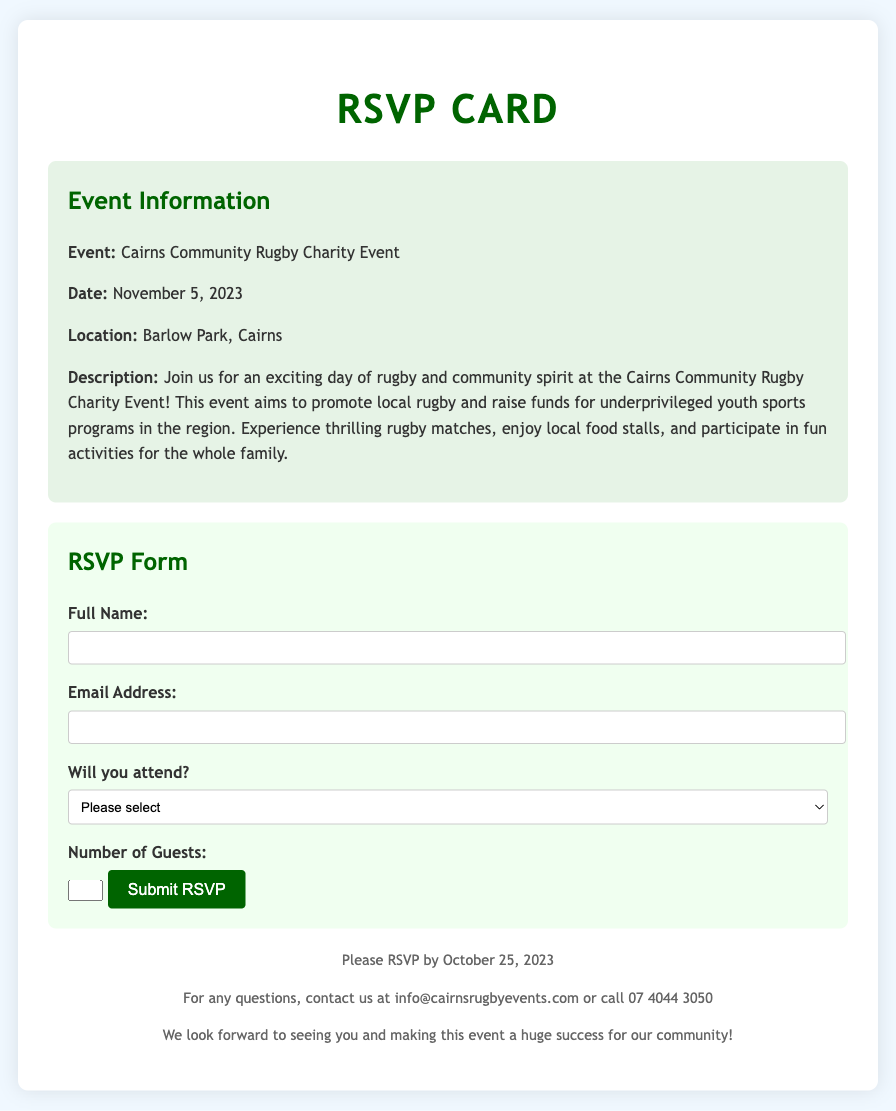What is the date of the event? The date of the Cairns Community Rugby Charity Event is explicitly stated in the document.
Answer: November 5, 2023 Where is the event taking place? The document specifies the location for the Cairns Community Rugby Charity Event.
Answer: Barlow Park, Cairns What is the main purpose of the event? The document describes the main purpose of the event, which involves promoting local rugby and fundraising.
Answer: Raise funds for underprivileged youth sports programs What is the RSVP deadline? The document mentions the last date by which attendees should RSVP for the event.
Answer: October 25, 2023 What information is required to submit the RSVP form? The document lists the necessary fields that must be filled out in the RSVP form.
Answer: Full Name, Email Address, Will you attend?, Number of Guests What activities can attendees expect at the event? The document provides an overview of activities available at the Cairns Community Rugby Charity Event.
Answer: Rugby matches, local food stalls, fun activities How can attendees reach out for questions? The document includes contact information for inquiries regarding the event.
Answer: info@cairnsrugbyevents.com or call 07 4044 3050 What is the maximum number of guests allowed? The RSVP form specifies a limit on the number of guests that can be included in the RSVP.
Answer: 5 